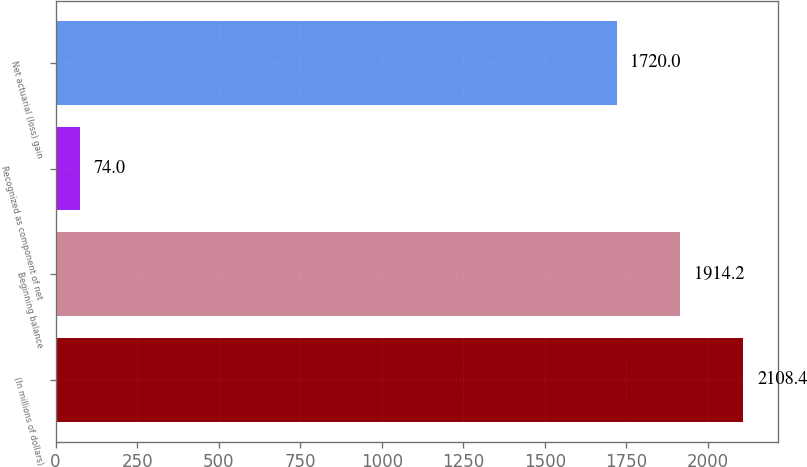Convert chart to OTSL. <chart><loc_0><loc_0><loc_500><loc_500><bar_chart><fcel>(In millions of dollars)<fcel>Beginning balance<fcel>Recognized as component of net<fcel>Net actuarial (loss) gain<nl><fcel>2108.4<fcel>1914.2<fcel>74<fcel>1720<nl></chart> 